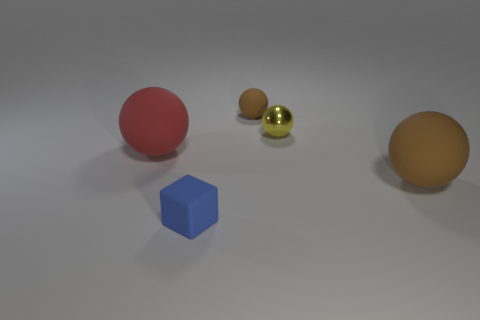Are there fewer objects that are behind the small blue thing than tiny brown rubber balls? Upon observing the image closely, it appears that there is a total of three objects situated behind the small blue cube. Starting from the left and moving right, there is a relatively large reddish sphere, followed by two smaller balls—one appears to be a shiny gold color and the other a matte brown, resembling rubber. In contrast, there is only a single object that could be described as a 'tiny brown rubber ball.' Thus, it is accurate to say that there are more objects behind the blue cube than there are tiny brown rubber balls in the entire scene. 